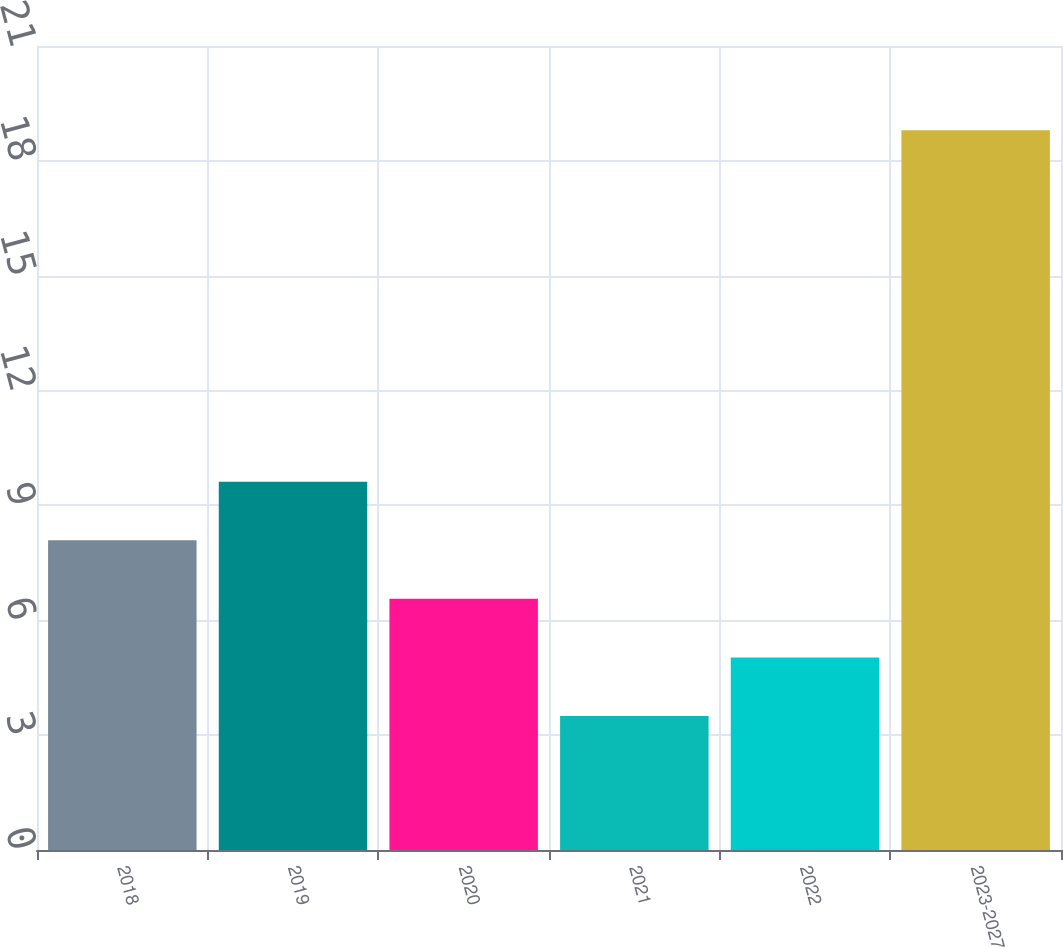Convert chart. <chart><loc_0><loc_0><loc_500><loc_500><bar_chart><fcel>2018<fcel>2019<fcel>2020<fcel>2021<fcel>2022<fcel>2023-2027<nl><fcel>8.09<fcel>9.62<fcel>6.56<fcel>3.5<fcel>5.03<fcel>18.8<nl></chart> 